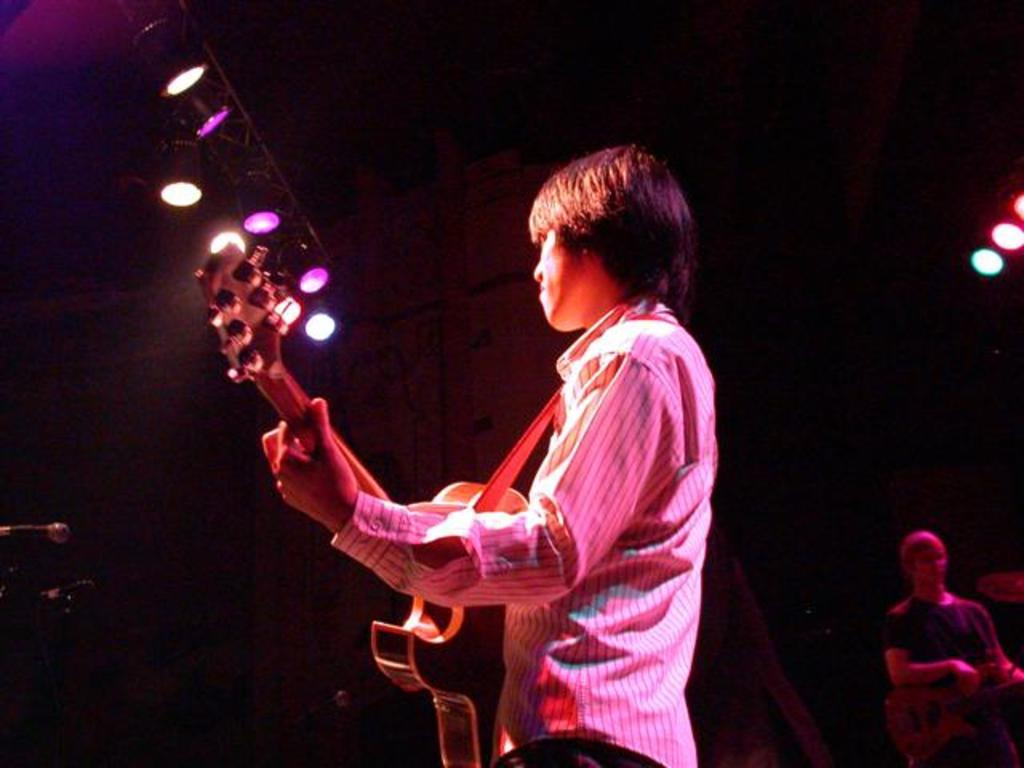Who is the main subject in the image? There is a man in the image. What is the man doing in the image? The man is playing a guitar. Where is the man located in the image? The man is on a stage. What type of bike can be seen in the image? There is no bike present in the image. How many ants are crawling on the guitar in the image? There are no ants present in the image. 